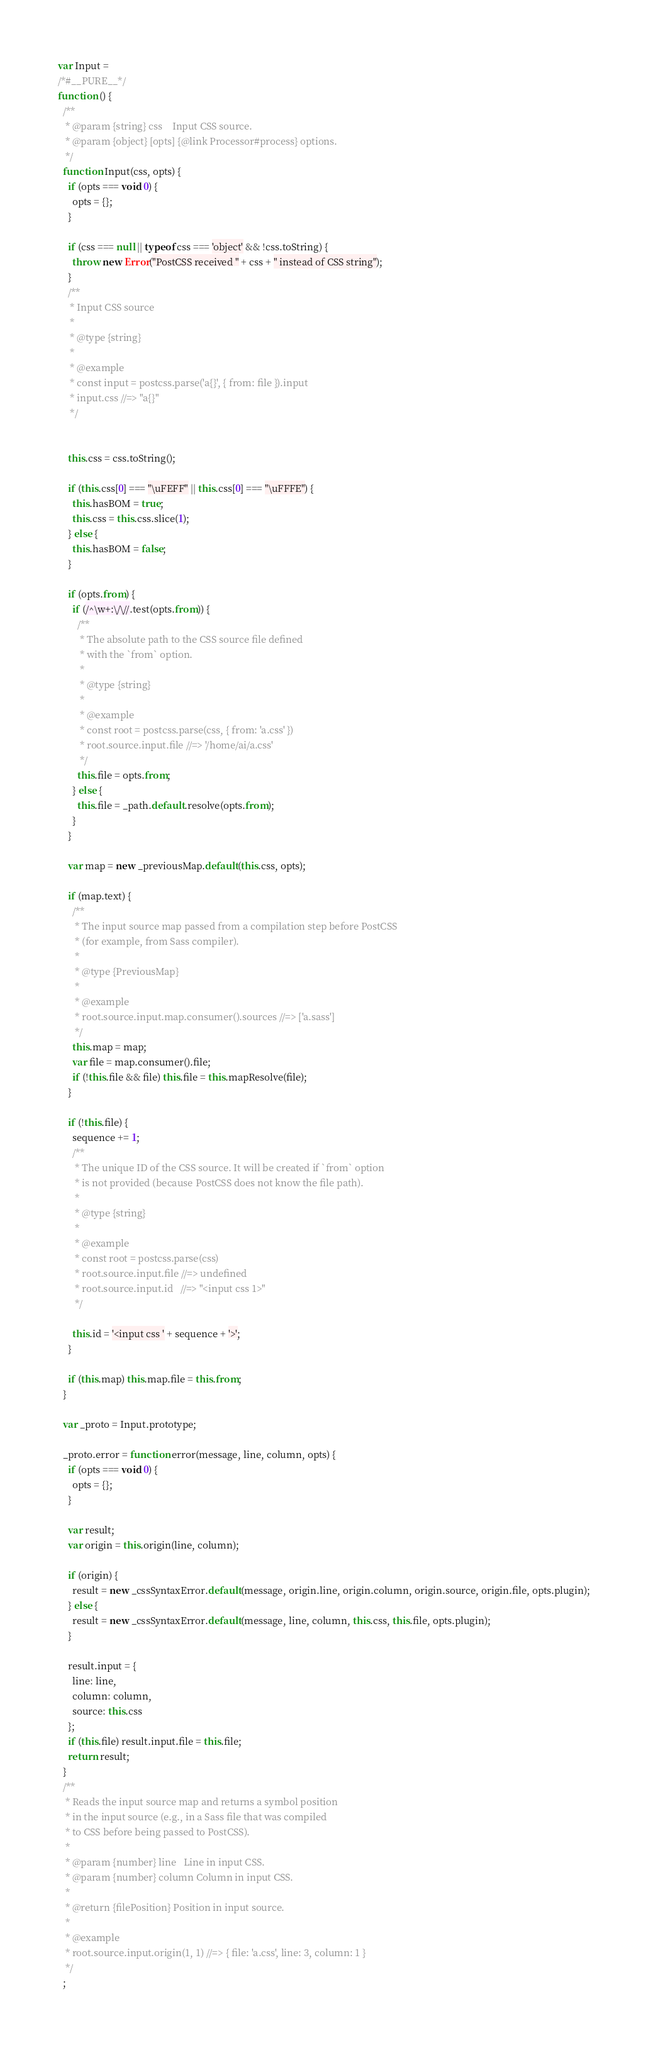Convert code to text. <code><loc_0><loc_0><loc_500><loc_500><_JavaScript_>
var Input =
/*#__PURE__*/
function () {
  /**
   * @param {string} css    Input CSS source.
   * @param {object} [opts] {@link Processor#process} options.
   */
  function Input(css, opts) {
    if (opts === void 0) {
      opts = {};
    }

    if (css === null || typeof css === 'object' && !css.toString) {
      throw new Error("PostCSS received " + css + " instead of CSS string");
    }
    /**
     * Input CSS source
     *
     * @type {string}
     *
     * @example
     * const input = postcss.parse('a{}', { from: file }).input
     * input.css //=> "a{}"
     */


    this.css = css.toString();

    if (this.css[0] === "\uFEFF" || this.css[0] === "\uFFFE") {
      this.hasBOM = true;
      this.css = this.css.slice(1);
    } else {
      this.hasBOM = false;
    }

    if (opts.from) {
      if (/^\w+:\/\//.test(opts.from)) {
        /**
         * The absolute path to the CSS source file defined
         * with the `from` option.
         *
         * @type {string}
         *
         * @example
         * const root = postcss.parse(css, { from: 'a.css' })
         * root.source.input.file //=> '/home/ai/a.css'
         */
        this.file = opts.from;
      } else {
        this.file = _path.default.resolve(opts.from);
      }
    }

    var map = new _previousMap.default(this.css, opts);

    if (map.text) {
      /**
       * The input source map passed from a compilation step before PostCSS
       * (for example, from Sass compiler).
       *
       * @type {PreviousMap}
       *
       * @example
       * root.source.input.map.consumer().sources //=> ['a.sass']
       */
      this.map = map;
      var file = map.consumer().file;
      if (!this.file && file) this.file = this.mapResolve(file);
    }

    if (!this.file) {
      sequence += 1;
      /**
       * The unique ID of the CSS source. It will be created if `from` option
       * is not provided (because PostCSS does not know the file path).
       *
       * @type {string}
       *
       * @example
       * const root = postcss.parse(css)
       * root.source.input.file //=> undefined
       * root.source.input.id   //=> "<input css 1>"
       */

      this.id = '<input css ' + sequence + '>';
    }

    if (this.map) this.map.file = this.from;
  }

  var _proto = Input.prototype;

  _proto.error = function error(message, line, column, opts) {
    if (opts === void 0) {
      opts = {};
    }

    var result;
    var origin = this.origin(line, column);

    if (origin) {
      result = new _cssSyntaxError.default(message, origin.line, origin.column, origin.source, origin.file, opts.plugin);
    } else {
      result = new _cssSyntaxError.default(message, line, column, this.css, this.file, opts.plugin);
    }

    result.input = {
      line: line,
      column: column,
      source: this.css
    };
    if (this.file) result.input.file = this.file;
    return result;
  }
  /**
   * Reads the input source map and returns a symbol position
   * in the input source (e.g., in a Sass file that was compiled
   * to CSS before being passed to PostCSS).
   *
   * @param {number} line   Line in input CSS.
   * @param {number} column Column in input CSS.
   *
   * @return {filePosition} Position in input source.
   *
   * @example
   * root.source.input.origin(1, 1) //=> { file: 'a.css', line: 3, column: 1 }
   */
  ;
</code> 